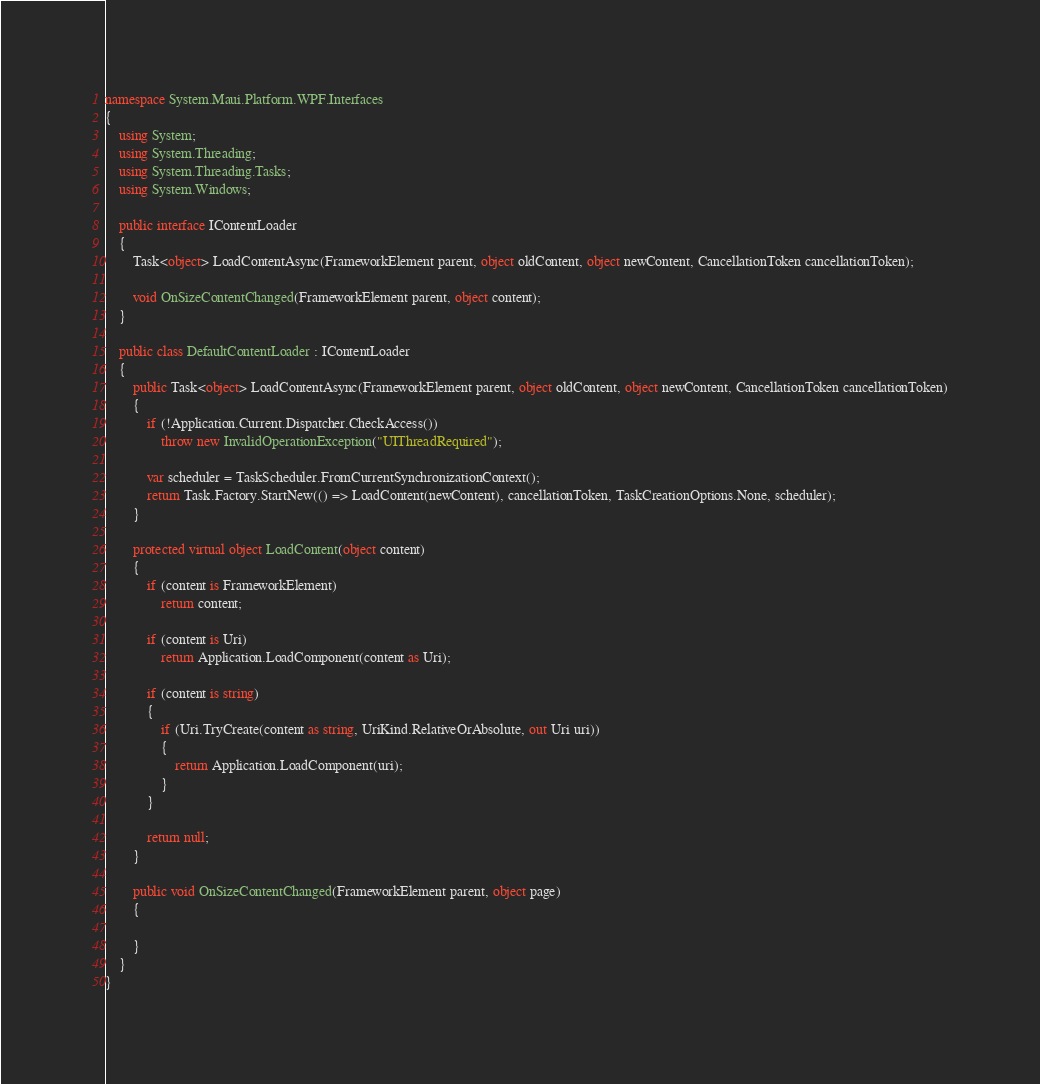Convert code to text. <code><loc_0><loc_0><loc_500><loc_500><_C#_>namespace System.Maui.Platform.WPF.Interfaces
{
	using System;
	using System.Threading;
	using System.Threading.Tasks;
	using System.Windows;

	public interface IContentLoader
	{
		Task<object> LoadContentAsync(FrameworkElement parent, object oldContent, object newContent, CancellationToken cancellationToken);

		void OnSizeContentChanged(FrameworkElement parent, object content);
	}

	public class DefaultContentLoader : IContentLoader
	{
		public Task<object> LoadContentAsync(FrameworkElement parent, object oldContent, object newContent, CancellationToken cancellationToken)
		{
			if (!Application.Current.Dispatcher.CheckAccess())
				throw new InvalidOperationException("UIThreadRequired");

			var scheduler = TaskScheduler.FromCurrentSynchronizationContext();
			return Task.Factory.StartNew(() => LoadContent(newContent), cancellationToken, TaskCreationOptions.None, scheduler);
		}

		protected virtual object LoadContent(object content)
		{
			if (content is FrameworkElement)
				return content;

			if (content is Uri)
				return Application.LoadComponent(content as Uri);

			if (content is string)
			{
				if (Uri.TryCreate(content as string, UriKind.RelativeOrAbsolute, out Uri uri))
				{
					return Application.LoadComponent(uri);
				}
			}

			return null;
		}

		public void OnSizeContentChanged(FrameworkElement parent, object page)
		{

		}
	}
}</code> 